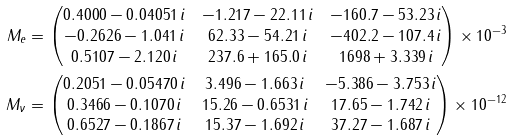Convert formula to latex. <formula><loc_0><loc_0><loc_500><loc_500>M _ { e } & = \begin{pmatrix} 0 . 4 0 0 0 - 0 . 0 4 0 5 1 \, i & - 1 . 2 1 7 - 2 2 . 1 1 \, i & - 1 6 0 . 7 - 5 3 . 2 3 \, i \\ - 0 . 2 6 2 6 - 1 . 0 4 1 \, i & 6 2 . 3 3 - 5 4 . 2 1 \, i & - 4 0 2 . 2 - 1 0 7 . 4 \, i \\ 0 . 5 1 0 7 - 2 . 1 2 0 \, i & 2 3 7 . 6 + 1 6 5 . 0 \, i & 1 6 9 8 + 3 . 3 3 9 \, i \end{pmatrix} \times 1 0 ^ { - 3 } \\ M _ { \nu } & = \begin{pmatrix} 0 . 2 0 5 1 - 0 . 0 5 4 7 0 \, i & 3 . 4 9 6 - 1 . 6 6 3 \, i & - 5 . 3 8 6 - 3 . 7 5 3 \, i \\ 0 . 3 4 6 6 - 0 . 1 0 7 0 \, i & 1 5 . 2 6 - 0 . 6 5 3 1 \, i & 1 7 . 6 5 - 1 . 7 4 2 \, i \\ 0 . 6 5 2 7 - 0 . 1 8 6 7 \, i & 1 5 . 3 7 - 1 . 6 9 2 \, i & 3 7 . 2 7 - 1 . 6 8 7 \, i \end{pmatrix} \times 1 0 ^ { - 1 2 }</formula> 